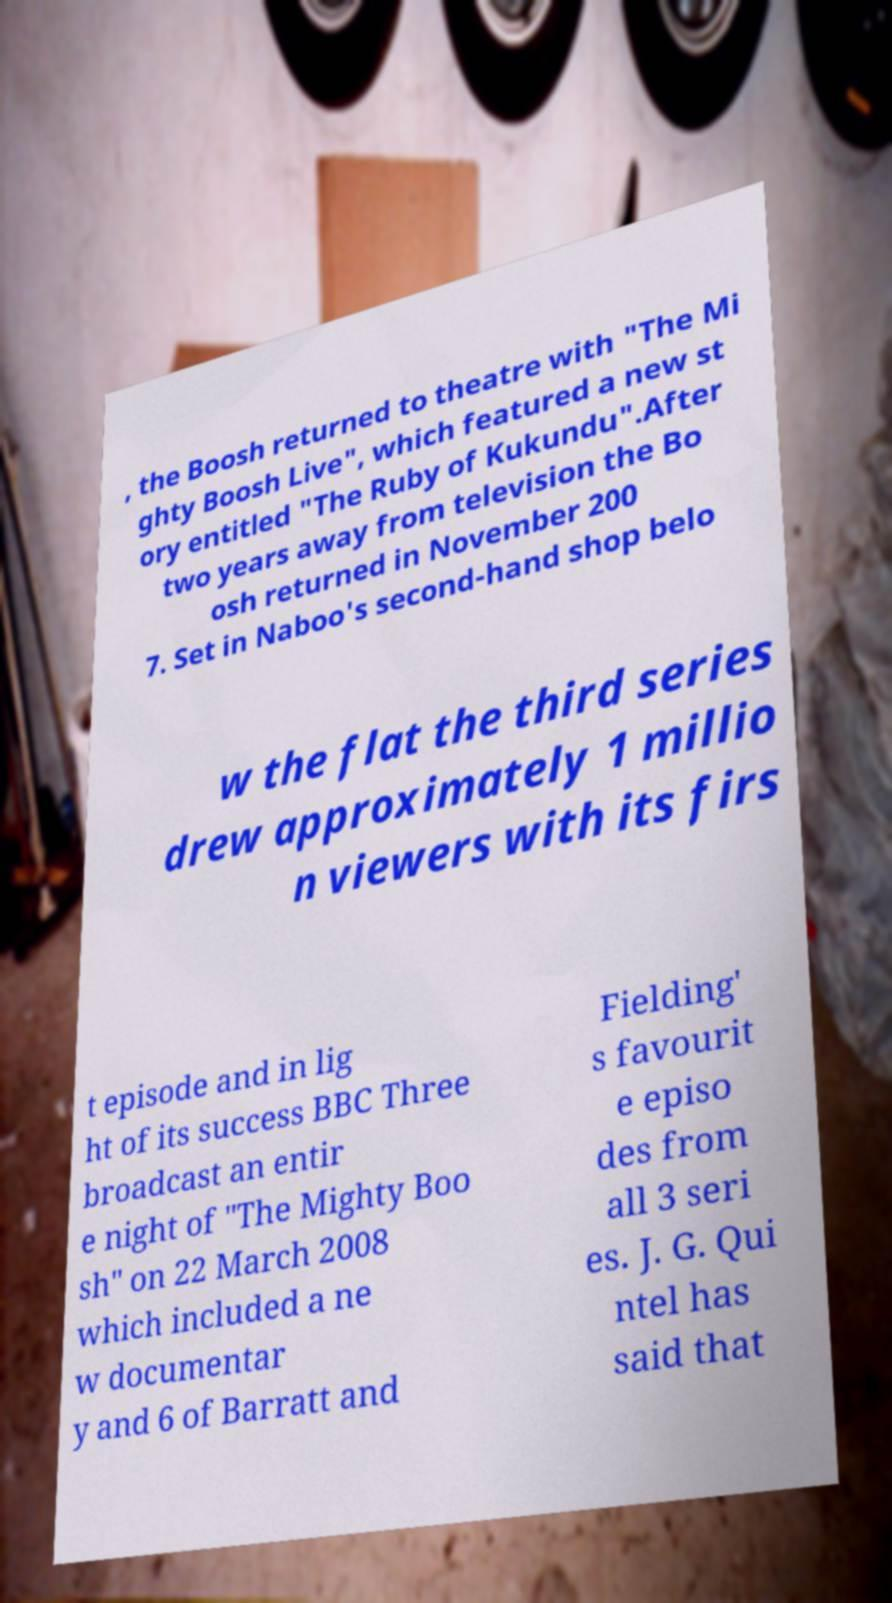I need the written content from this picture converted into text. Can you do that? , the Boosh returned to theatre with "The Mi ghty Boosh Live", which featured a new st ory entitled "The Ruby of Kukundu".After two years away from television the Bo osh returned in November 200 7. Set in Naboo's second-hand shop belo w the flat the third series drew approximately 1 millio n viewers with its firs t episode and in lig ht of its success BBC Three broadcast an entir e night of "The Mighty Boo sh" on 22 March 2008 which included a ne w documentar y and 6 of Barratt and Fielding' s favourit e episo des from all 3 seri es. J. G. Qui ntel has said that 